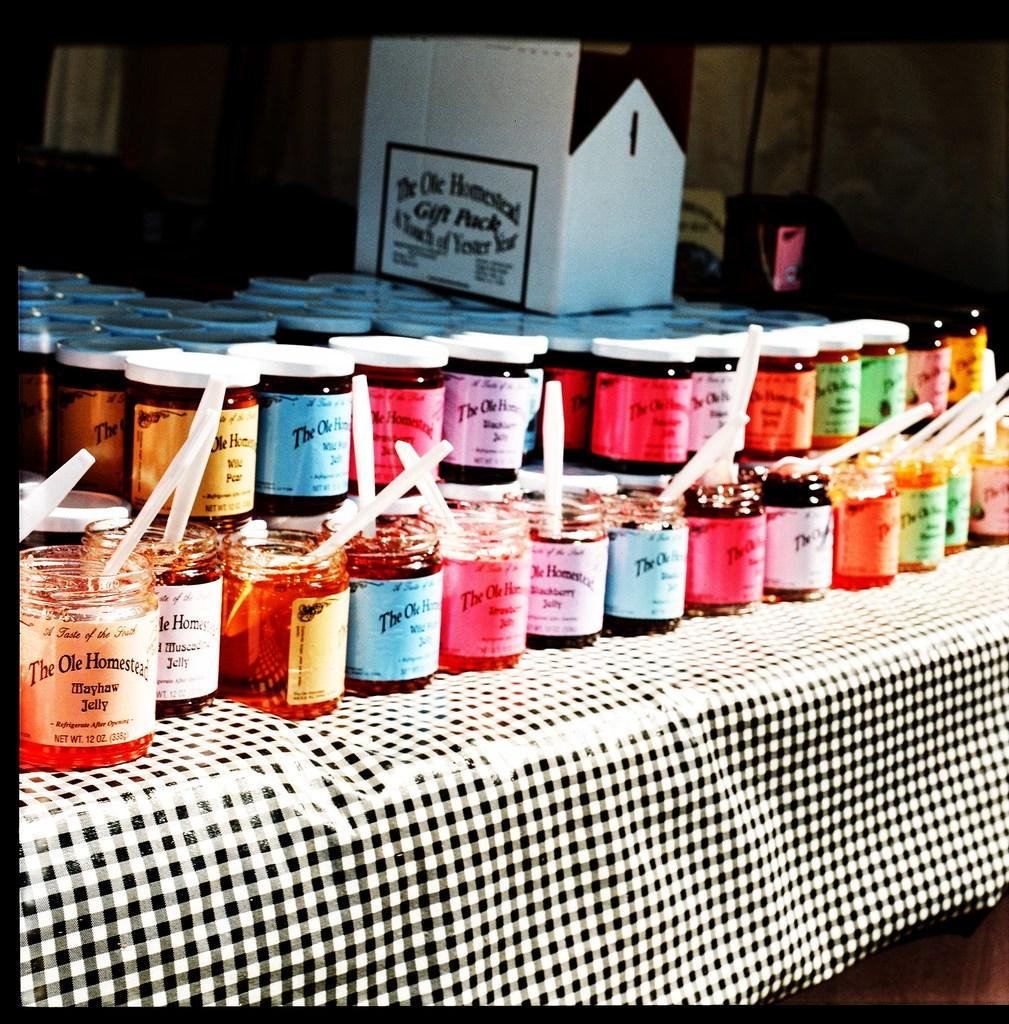<image>
Write a terse but informative summary of the picture. A table with several different flavored Jams with a box in the back reading "The Ole Homestead". 